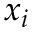<formula> <loc_0><loc_0><loc_500><loc_500>x _ { i }</formula> 